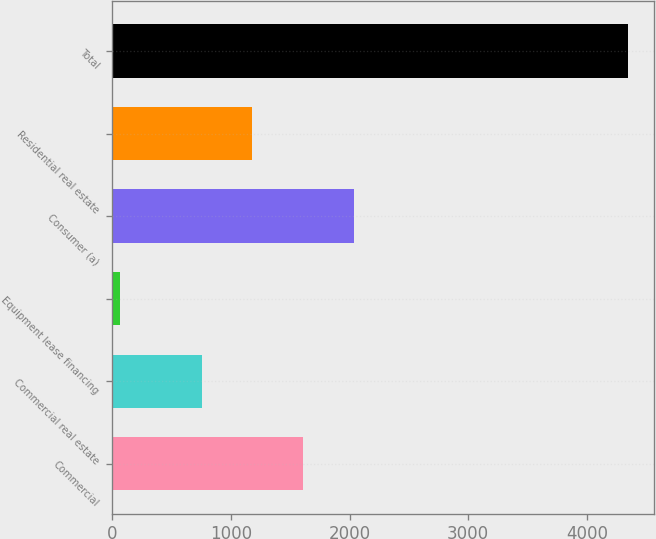Convert chart to OTSL. <chart><loc_0><loc_0><loc_500><loc_500><bar_chart><fcel>Commercial<fcel>Commercial real estate<fcel>Equipment lease financing<fcel>Consumer (a)<fcel>Residential real estate<fcel>Total<nl><fcel>1610<fcel>753<fcel>62<fcel>2038.5<fcel>1181.5<fcel>4347<nl></chart> 